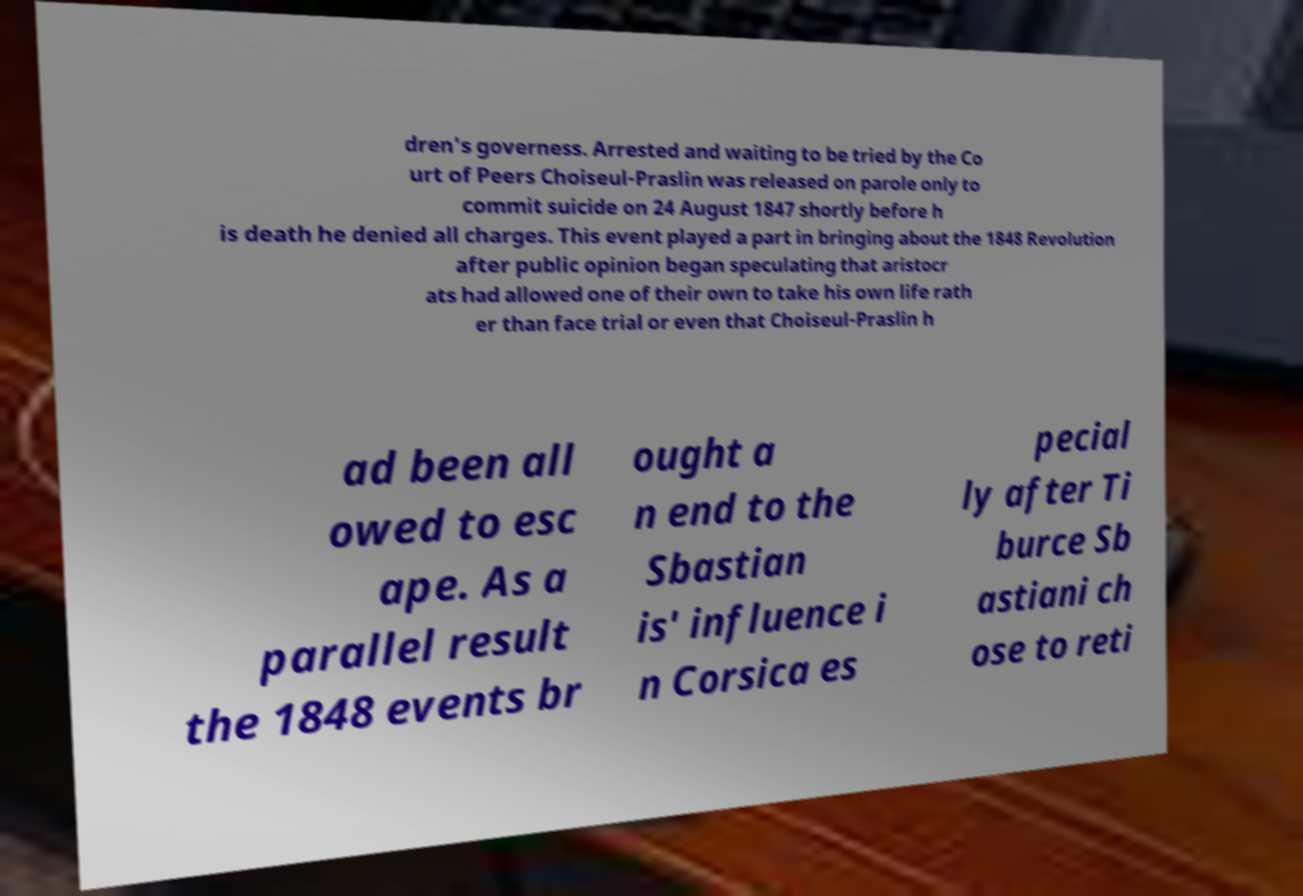There's text embedded in this image that I need extracted. Can you transcribe it verbatim? dren's governess. Arrested and waiting to be tried by the Co urt of Peers Choiseul-Praslin was released on parole only to commit suicide on 24 August 1847 shortly before h is death he denied all charges. This event played a part in bringing about the 1848 Revolution after public opinion began speculating that aristocr ats had allowed one of their own to take his own life rath er than face trial or even that Choiseul-Praslin h ad been all owed to esc ape. As a parallel result the 1848 events br ought a n end to the Sbastian is' influence i n Corsica es pecial ly after Ti burce Sb astiani ch ose to reti 